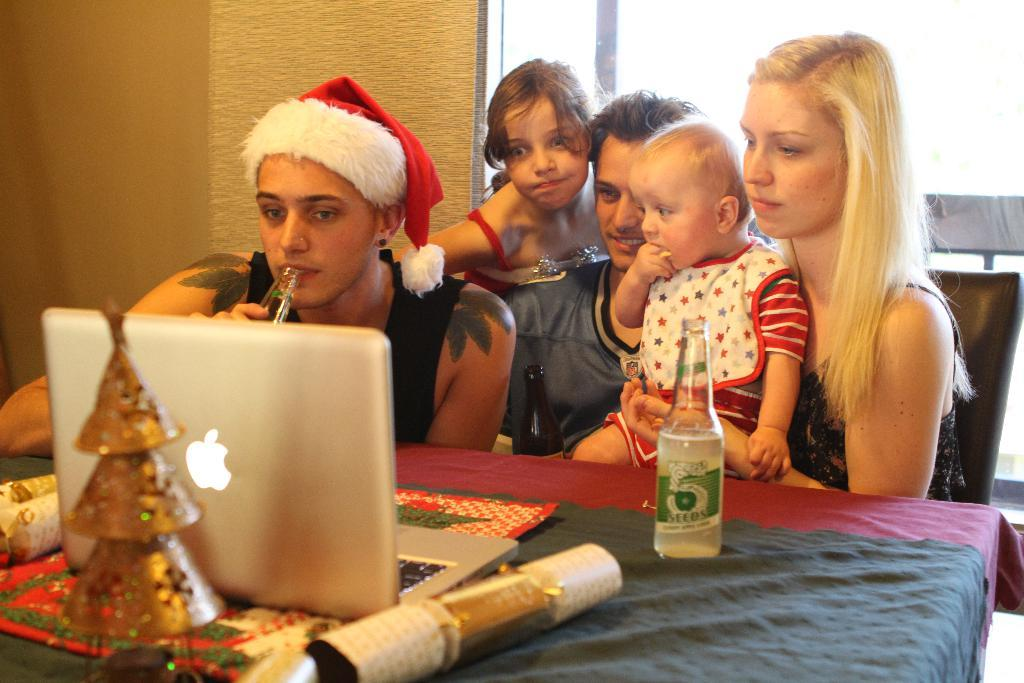How many people are in the image? There are three persons in the image. How many of them are children? There are two children in the image. What objects can be seen on the table in the image? There is a bottle and a laptop on the table. What type of fruit is hanging from the structure in the image? There is no fruit or structure present in the image. 